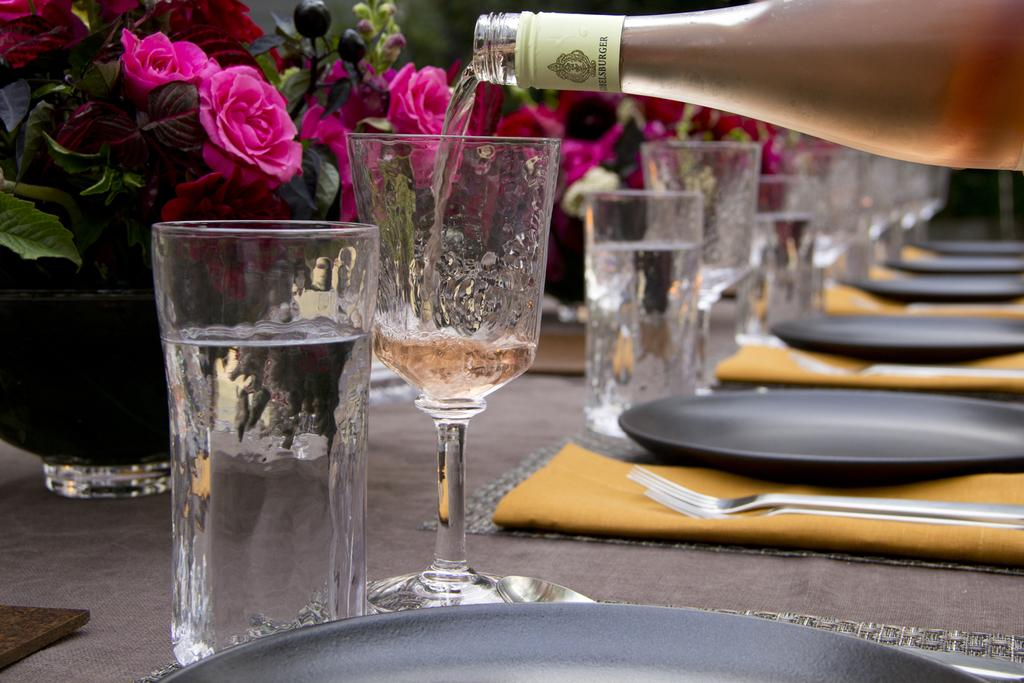What type of tableware can be seen in the image? There are glasses, plates, and spoons in the image. What else is present in the image besides tableware? There are clothes and flowers in the image. What type of container is visible in the image? There is a bottle in the image. What type of memory is being used by the chickens in the image? There are no chickens present in the image, so the concept of memory does not apply. 